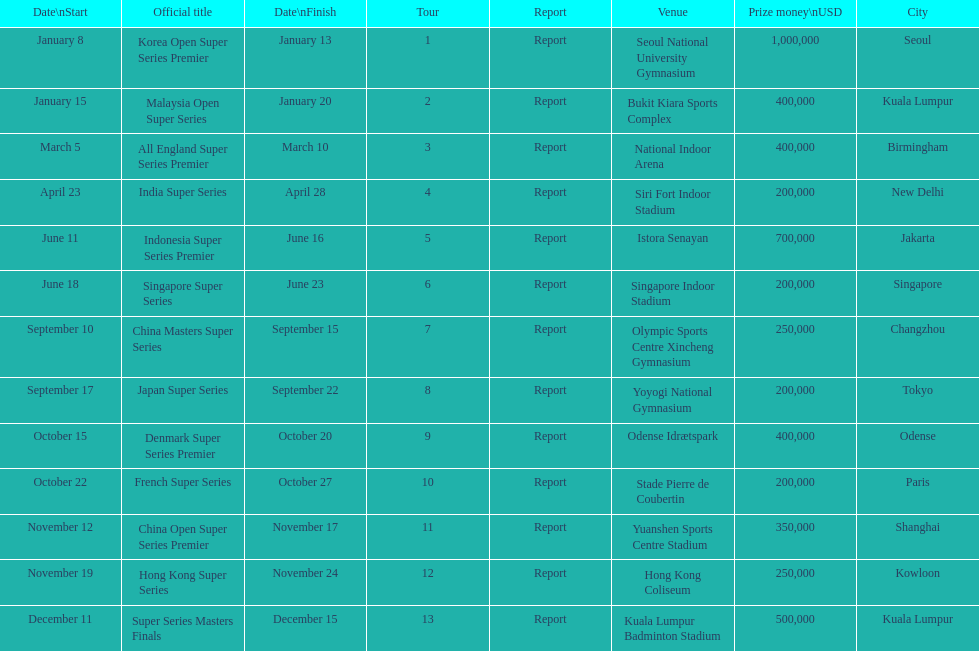Parse the table in full. {'header': ['Date\\nStart', 'Official title', 'Date\\nFinish', 'Tour', 'Report', 'Venue', 'Prize money\\nUSD', 'City'], 'rows': [['January 8', 'Korea Open Super Series Premier', 'January 13', '1', 'Report', 'Seoul National University Gymnasium', '1,000,000', 'Seoul'], ['January 15', 'Malaysia Open Super Series', 'January 20', '2', 'Report', 'Bukit Kiara Sports Complex', '400,000', 'Kuala Lumpur'], ['March 5', 'All England Super Series Premier', 'March 10', '3', 'Report', 'National Indoor Arena', '400,000', 'Birmingham'], ['April 23', 'India Super Series', 'April 28', '4', 'Report', 'Siri Fort Indoor Stadium', '200,000', 'New Delhi'], ['June 11', 'Indonesia Super Series Premier', 'June 16', '5', 'Report', 'Istora Senayan', '700,000', 'Jakarta'], ['June 18', 'Singapore Super Series', 'June 23', '6', 'Report', 'Singapore Indoor Stadium', '200,000', 'Singapore'], ['September 10', 'China Masters Super Series', 'September 15', '7', 'Report', 'Olympic Sports Centre Xincheng Gymnasium', '250,000', 'Changzhou'], ['September 17', 'Japan Super Series', 'September 22', '8', 'Report', 'Yoyogi National Gymnasium', '200,000', 'Tokyo'], ['October 15', 'Denmark Super Series Premier', 'October 20', '9', 'Report', 'Odense Idrætspark', '400,000', 'Odense'], ['October 22', 'French Super Series', 'October 27', '10', 'Report', 'Stade Pierre de Coubertin', '200,000', 'Paris'], ['November 12', 'China Open Super Series Premier', 'November 17', '11', 'Report', 'Yuanshen Sports Centre Stadium', '350,000', 'Shanghai'], ['November 19', 'Hong Kong Super Series', 'November 24', '12', 'Report', 'Hong Kong Coliseum', '250,000', 'Kowloon'], ['December 11', 'Super Series Masters Finals', 'December 15', '13', 'Report', 'Kuala Lumpur Badminton Stadium', '500,000', 'Kuala Lumpur']]} Does the malaysia open super series pay more or less than french super series? More. 